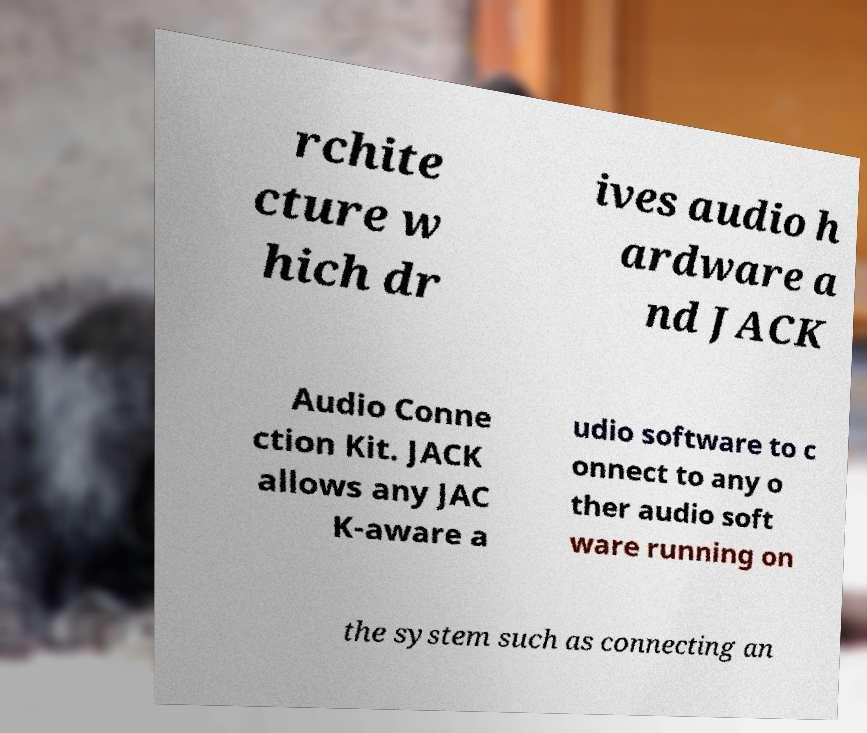Can you read and provide the text displayed in the image?This photo seems to have some interesting text. Can you extract and type it out for me? rchite cture w hich dr ives audio h ardware a nd JACK Audio Conne ction Kit. JACK allows any JAC K-aware a udio software to c onnect to any o ther audio soft ware running on the system such as connecting an 